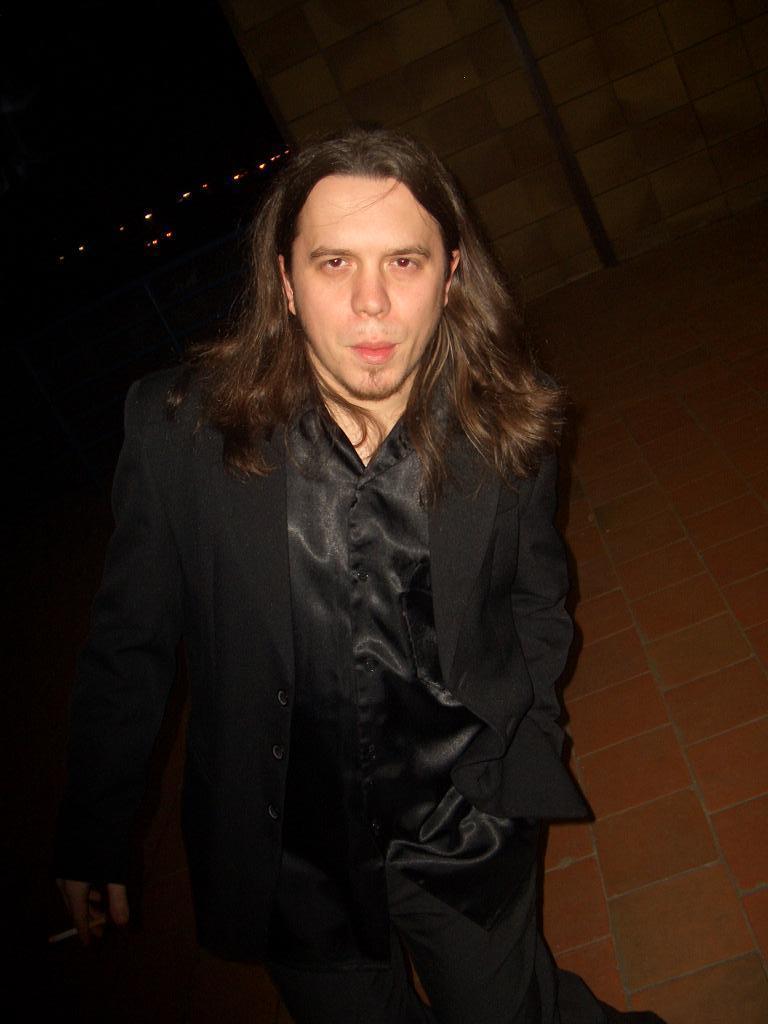Please provide a concise description of this image. In this image we can see a man standing. He is wearing a black suit. In the background there is a wall. 